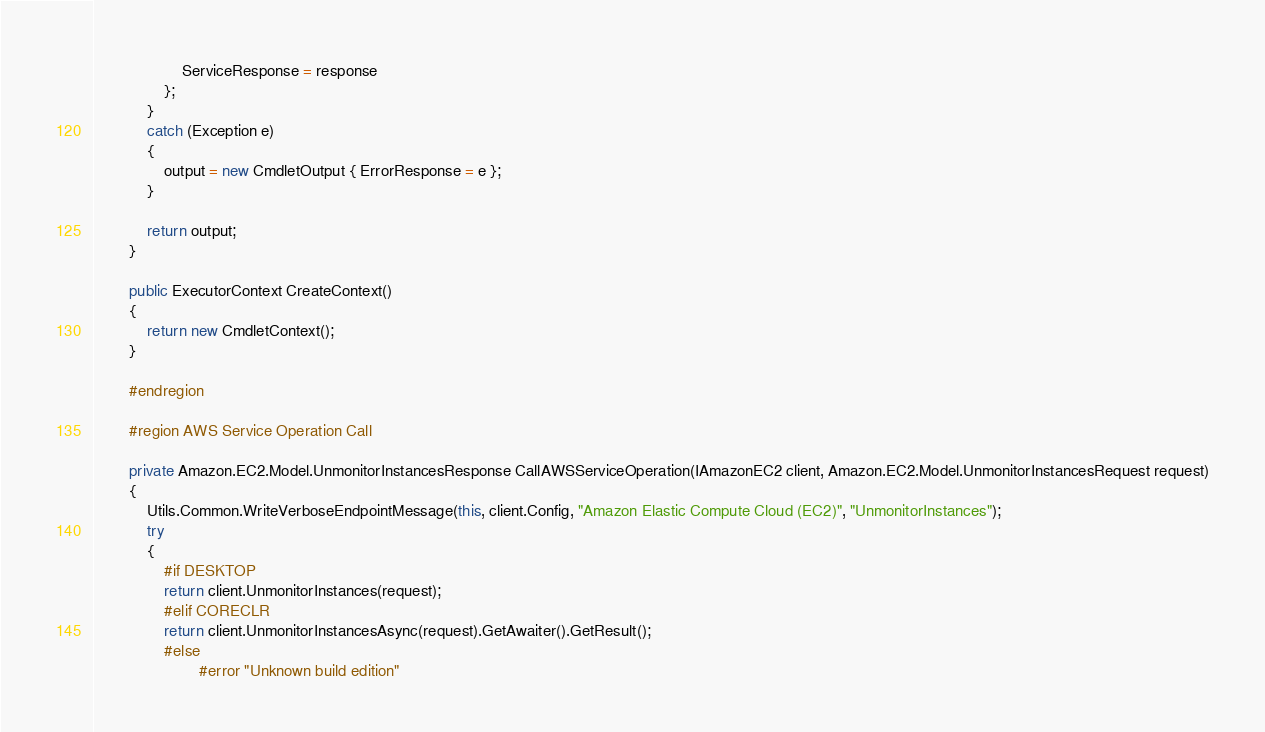<code> <loc_0><loc_0><loc_500><loc_500><_C#_>                    ServiceResponse = response
                };
            }
            catch (Exception e)
            {
                output = new CmdletOutput { ErrorResponse = e };
            }
            
            return output;
        }
        
        public ExecutorContext CreateContext()
        {
            return new CmdletContext();
        }
        
        #endregion
        
        #region AWS Service Operation Call
        
        private Amazon.EC2.Model.UnmonitorInstancesResponse CallAWSServiceOperation(IAmazonEC2 client, Amazon.EC2.Model.UnmonitorInstancesRequest request)
        {
            Utils.Common.WriteVerboseEndpointMessage(this, client.Config, "Amazon Elastic Compute Cloud (EC2)", "UnmonitorInstances");
            try
            {
                #if DESKTOP
                return client.UnmonitorInstances(request);
                #elif CORECLR
                return client.UnmonitorInstancesAsync(request).GetAwaiter().GetResult();
                #else
                        #error "Unknown build edition"</code> 